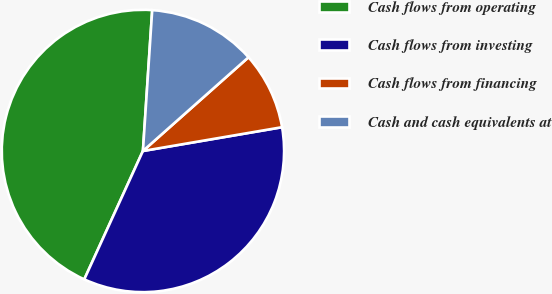Convert chart. <chart><loc_0><loc_0><loc_500><loc_500><pie_chart><fcel>Cash flows from operating<fcel>Cash flows from investing<fcel>Cash flows from financing<fcel>Cash and cash equivalents at<nl><fcel>44.23%<fcel>34.52%<fcel>8.86%<fcel>12.4%<nl></chart> 